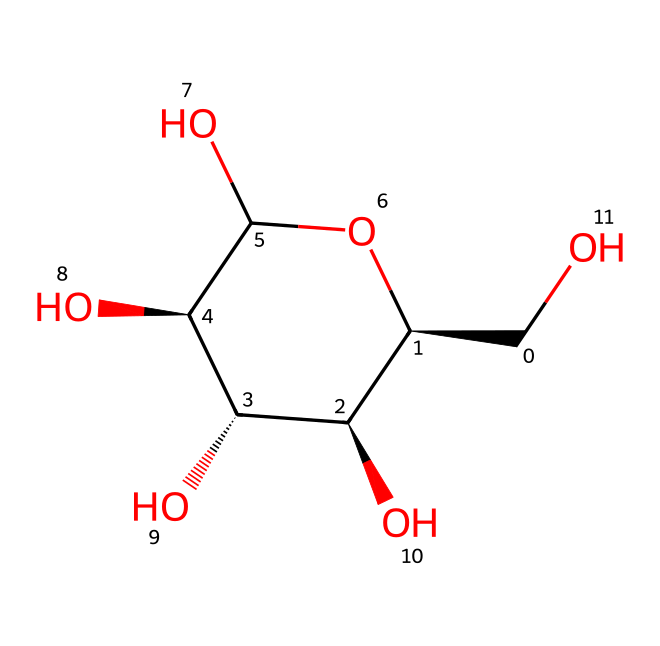How many carbon atoms are in the chemical structure? Counting the carbon atoms present in the SMILES representation reveals that there are 6 carbon atoms in total.
Answer: 6 What is the role of water in the suspension of cornstarch? Water acts as a medium that allows cornstarch molecules to disperse, providing the necessary environment for the formation of a non-Newtonian fluid.
Answer: medium What type of interaction occurs between cornstarch and water? The primary interaction is hydrogen bonding, as the hydroxyl groups on cornstarch can form hydrogen bonds with water molecules, promoting the suspension.
Answer: hydrogen bonding How many hydroxyl groups are present in this structure? By examining the SMILES notation, there are 5 hydroxyl (–OH) groups shown attached to the carbon backbone of the cornstarch molecule.
Answer: 5 What makes cornstarch a non-Newtonian fluid? The unique arrangement of starch granules and their response to shear stress results in the change of viscosity, classifying it as a non-Newtonian fluid.
Answer: shear stress Which part of the molecule is responsible for its thickening properties? The polymer chains formed by the repeated glucose units make the cornstarch viscous, contributing to its thickening ability in suspension.
Answer: polymer chains 